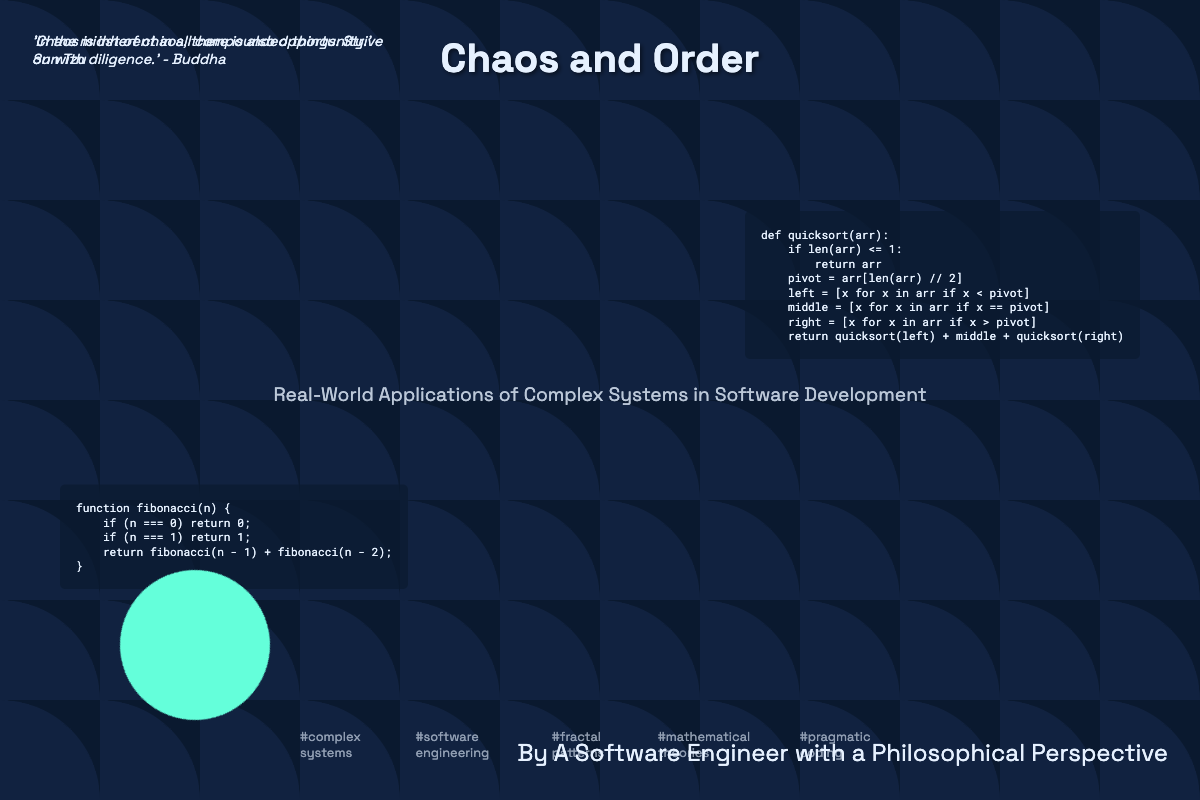What is the title of the book? The title is prominently displayed at the top of the cover.
Answer: Chaos and Order Who is the author of the book? The author's name is mentioned at the bottom of the cover.
Answer: A Software Engineer with a Philosophical Perspective What is the subtitle of the book? The subtitle provides additional context about the book's content.
Answer: Real-World Applications of Complex Systems in Software Development How many quotes are presented on the cover? There are two quotes credited to different authors.
Answer: 2 What color is used for the fractal pattern? The color of the fractal is specified in the SVG format within the code.
Answer: Light blue What coding algorithm is shown in the first code block? The type of algorithm is identified by its naming convention and format.
Answer: Quicksort What is the main theme of the keywords section? The keywords indicate the central topics covered in the book.
Answer: Complex systems What animation is applied to the engineer graphic? The animation effect is specified to give the graphic a dynamic quality.
Answer: Spin What is the opacity of the fractal pattern? The opacity level is provided in the style definition for the fractal class.
Answer: 0.2 